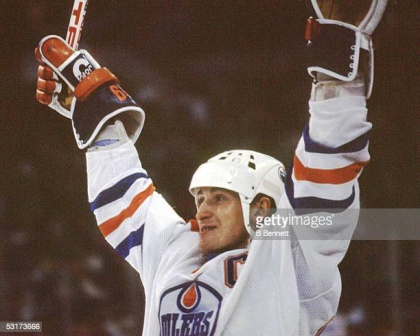Can you describe the crowd's reaction based on the player's expression and body language? Based on the player's jubilant expression and triumphant body language, it can be inferred that the crowd is erupting into loud cheers and applause. The collective energy in the rink is likely palpable, with fans standing up, waving their arms, and some even chanting the player's name or the team's slogan. The air is filled with a mix of excitement, pride, and sheer joy, as the crowd celebrates this high point of the game alongside their team hero. What kind of impact do moments like these have on a player's career? Moments like these are pivotal in a player's career, often becoming defining highlights. Such exhilarating experiences not only boost the player's confidence but also reinforce their dedication to the sport. They contribute significantly to a player's reputation, endearing them to fans and attracting media attention. These triumphant moments often serve as motivation, driving players to achieve even greater heights. Additionally, they can lead to increased endorsements and a higher market value, furthering the player's professional journey. If this image were part of a sports documentary, what title would fit best? A fitting title for a sports documentary featuring this image could be "Defining Moments: The Heart and Soul of Hockey Heroes". This title encapsulates the essence of the player's triumph and the emotional highs of the sport, reflecting the journey, dedication, and peak moments that define a player's career. 